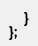Convert code to text. <code><loc_0><loc_0><loc_500><loc_500><_JavaScript_>
    }
};

</code> 